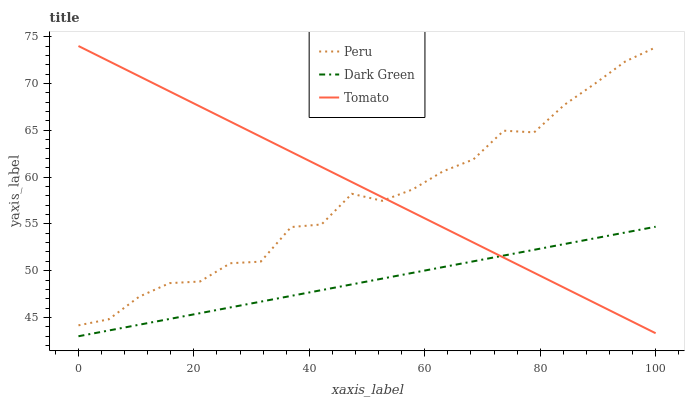Does Dark Green have the minimum area under the curve?
Answer yes or no. Yes. Does Tomato have the maximum area under the curve?
Answer yes or no. Yes. Does Peru have the minimum area under the curve?
Answer yes or no. No. Does Peru have the maximum area under the curve?
Answer yes or no. No. Is Dark Green the smoothest?
Answer yes or no. Yes. Is Peru the roughest?
Answer yes or no. Yes. Is Peru the smoothest?
Answer yes or no. No. Is Dark Green the roughest?
Answer yes or no. No. Does Dark Green have the lowest value?
Answer yes or no. Yes. Does Peru have the lowest value?
Answer yes or no. No. Does Tomato have the highest value?
Answer yes or no. Yes. Does Peru have the highest value?
Answer yes or no. No. Is Dark Green less than Peru?
Answer yes or no. Yes. Is Peru greater than Dark Green?
Answer yes or no. Yes. Does Dark Green intersect Tomato?
Answer yes or no. Yes. Is Dark Green less than Tomato?
Answer yes or no. No. Is Dark Green greater than Tomato?
Answer yes or no. No. Does Dark Green intersect Peru?
Answer yes or no. No. 